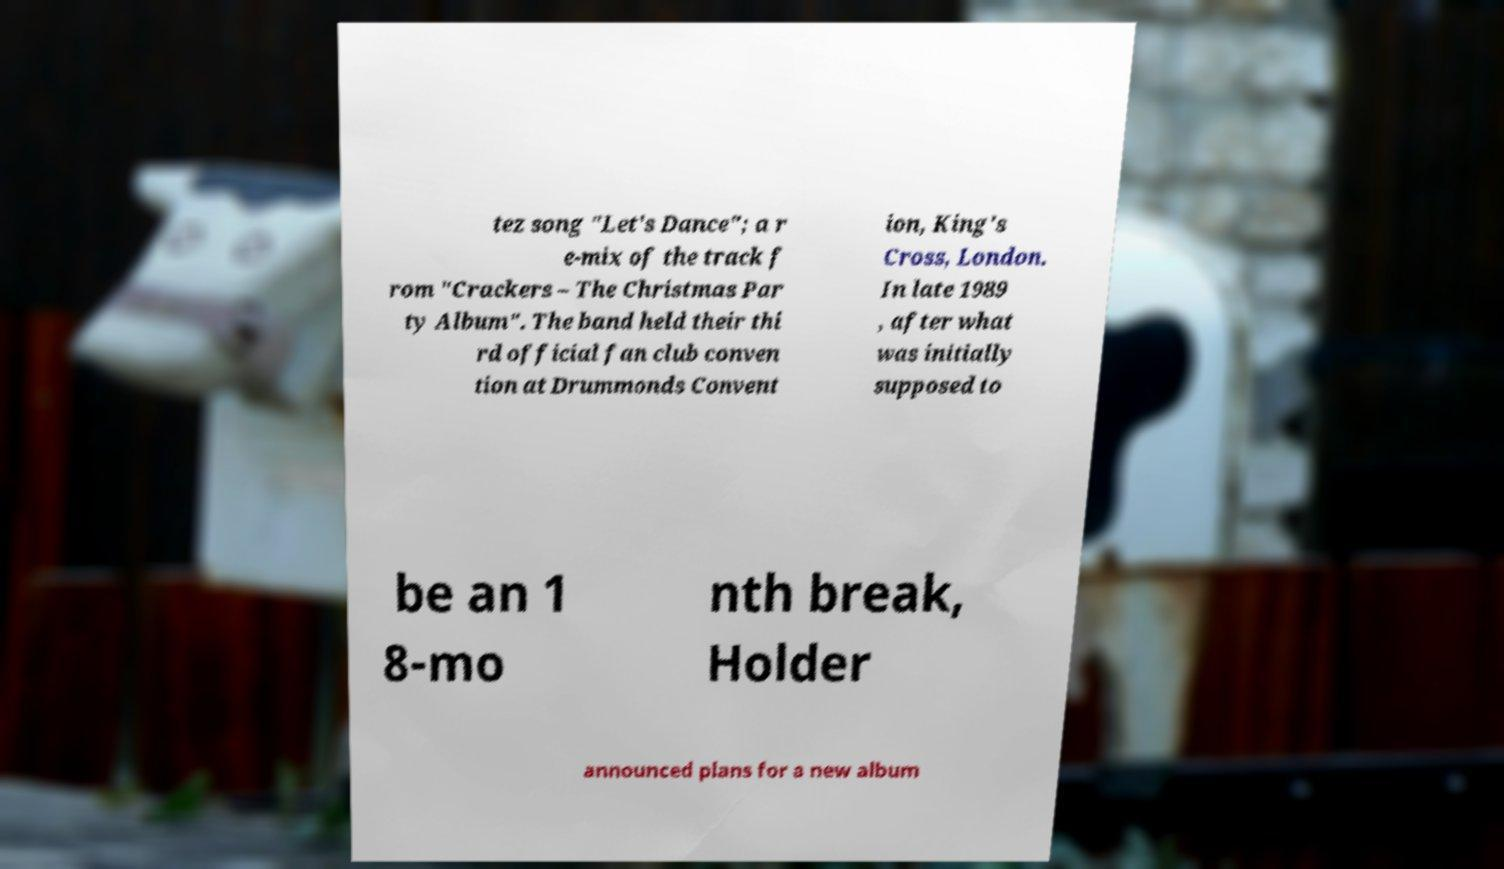Please identify and transcribe the text found in this image. tez song "Let's Dance"; a r e-mix of the track f rom "Crackers – The Christmas Par ty Album". The band held their thi rd official fan club conven tion at Drummonds Convent ion, King's Cross, London. In late 1989 , after what was initially supposed to be an 1 8-mo nth break, Holder announced plans for a new album 